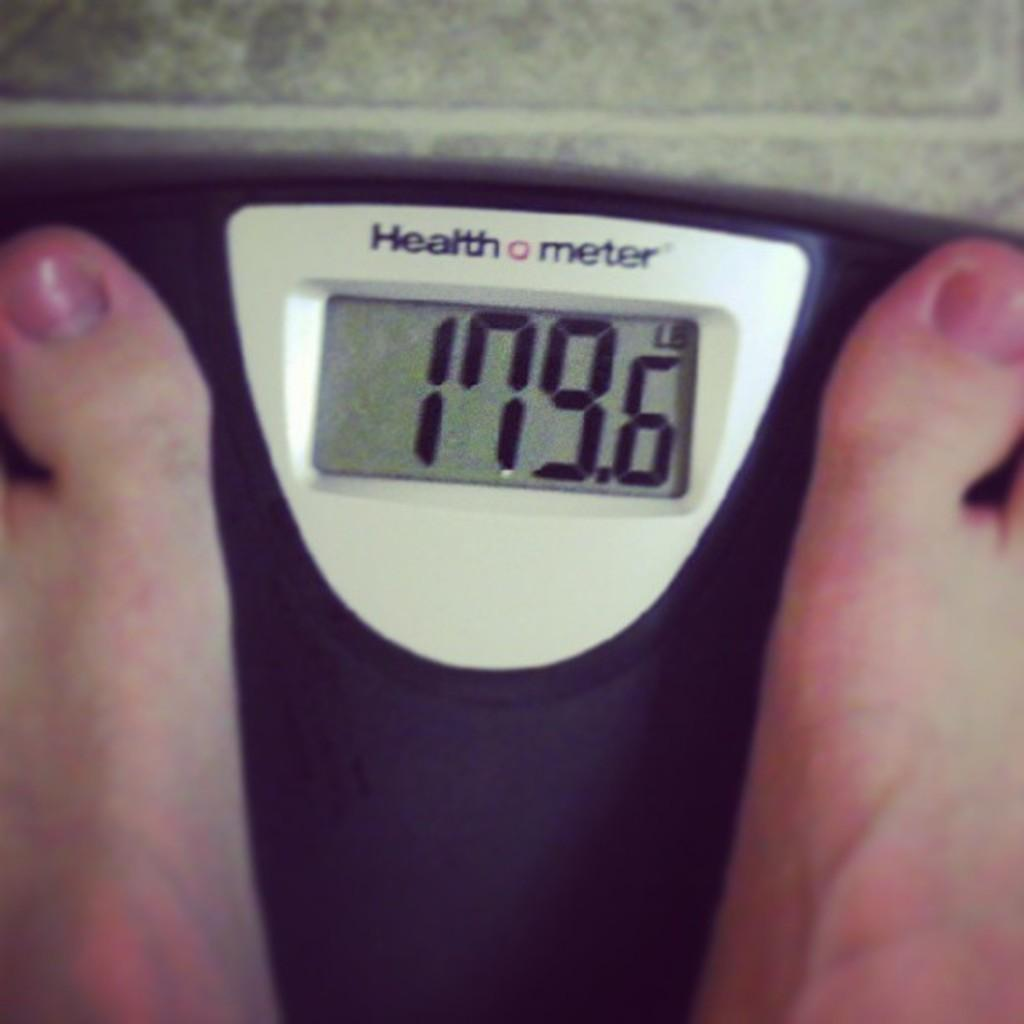<image>
Relay a brief, clear account of the picture shown. The person on the Health Meter weighs 179.6 pounds. 